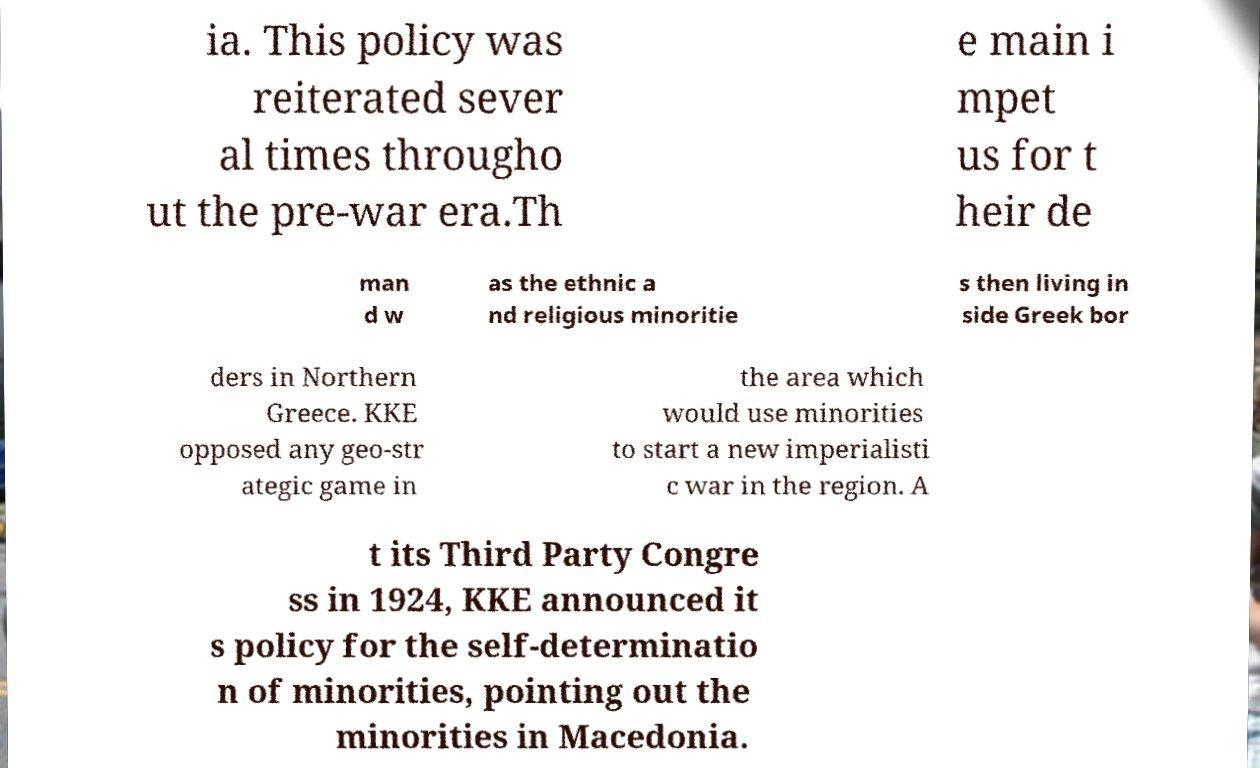Please identify and transcribe the text found in this image. ia. This policy was reiterated sever al times througho ut the pre-war era.Th e main i mpet us for t heir de man d w as the ethnic a nd religious minoritie s then living in side Greek bor ders in Northern Greece. KKE opposed any geo-str ategic game in the area which would use minorities to start a new imperialisti c war in the region. A t its Third Party Congre ss in 1924, KKE announced it s policy for the self-determinatio n of minorities, pointing out the minorities in Macedonia. 